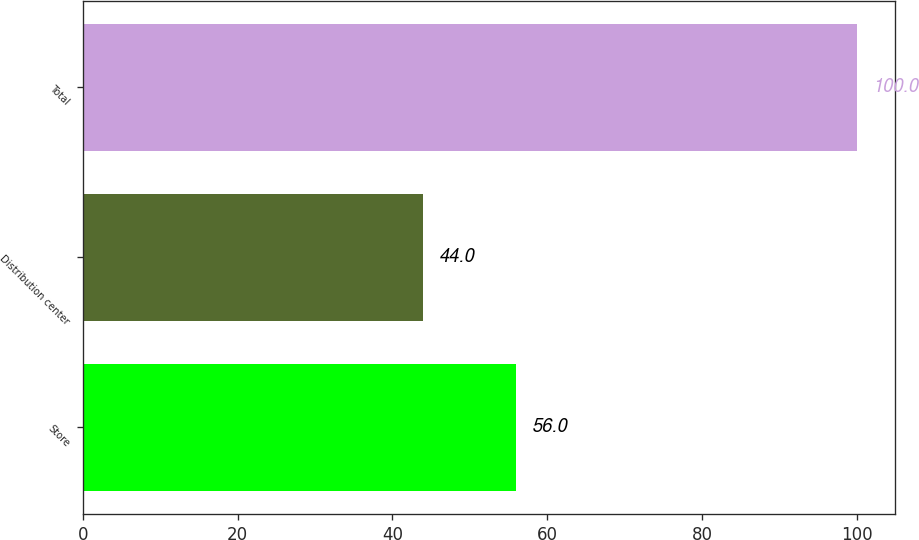<chart> <loc_0><loc_0><loc_500><loc_500><bar_chart><fcel>Store<fcel>Distribution center<fcel>Total<nl><fcel>56<fcel>44<fcel>100<nl></chart> 